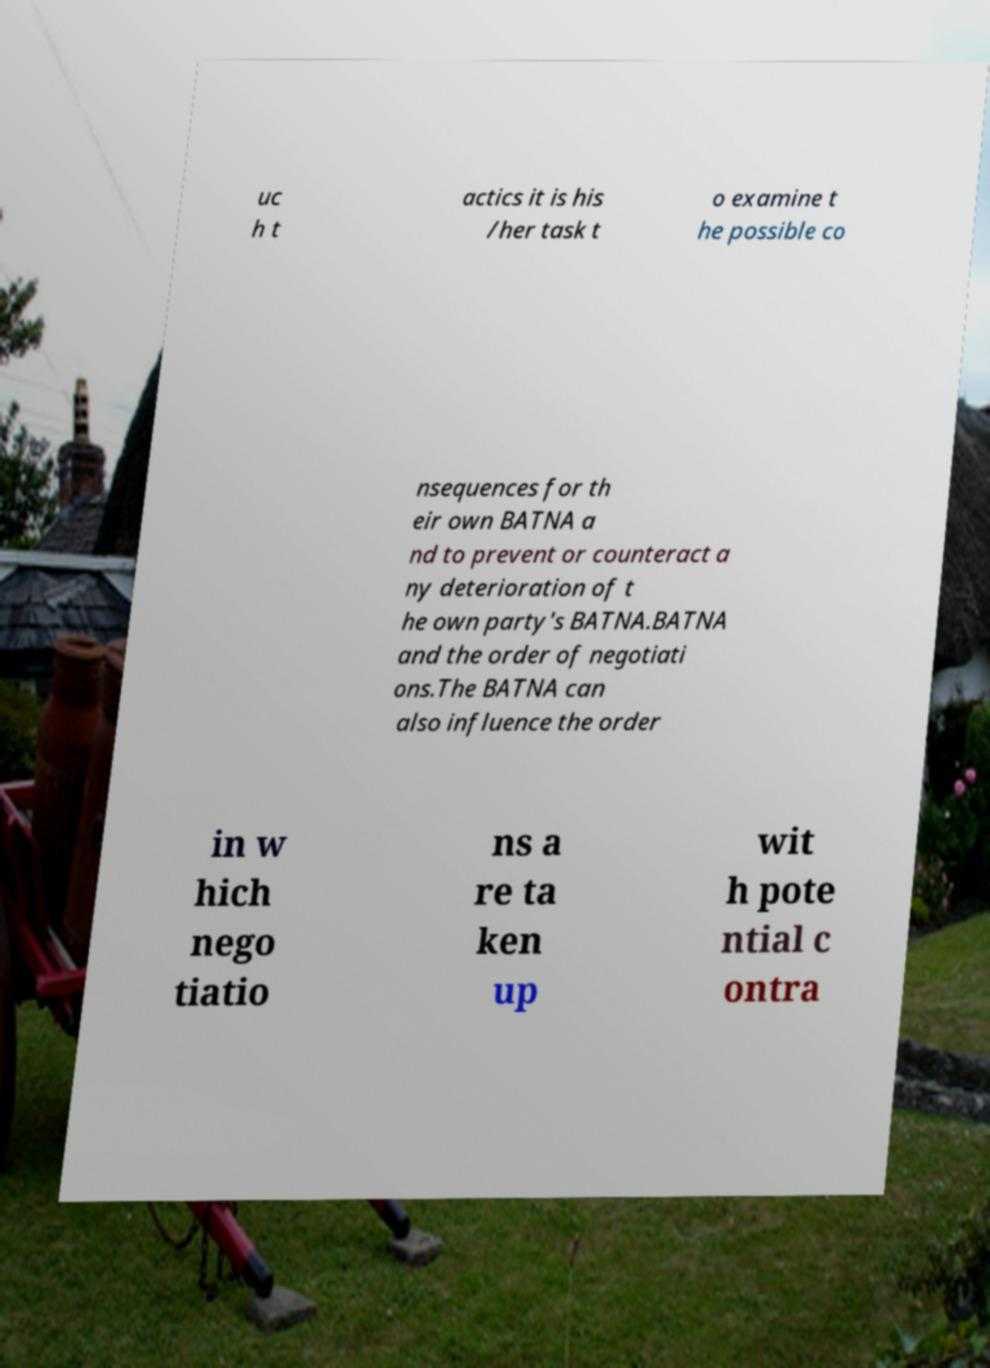For documentation purposes, I need the text within this image transcribed. Could you provide that? uc h t actics it is his /her task t o examine t he possible co nsequences for th eir own BATNA a nd to prevent or counteract a ny deterioration of t he own party's BATNA.BATNA and the order of negotiati ons.The BATNA can also influence the order in w hich nego tiatio ns a re ta ken up wit h pote ntial c ontra 